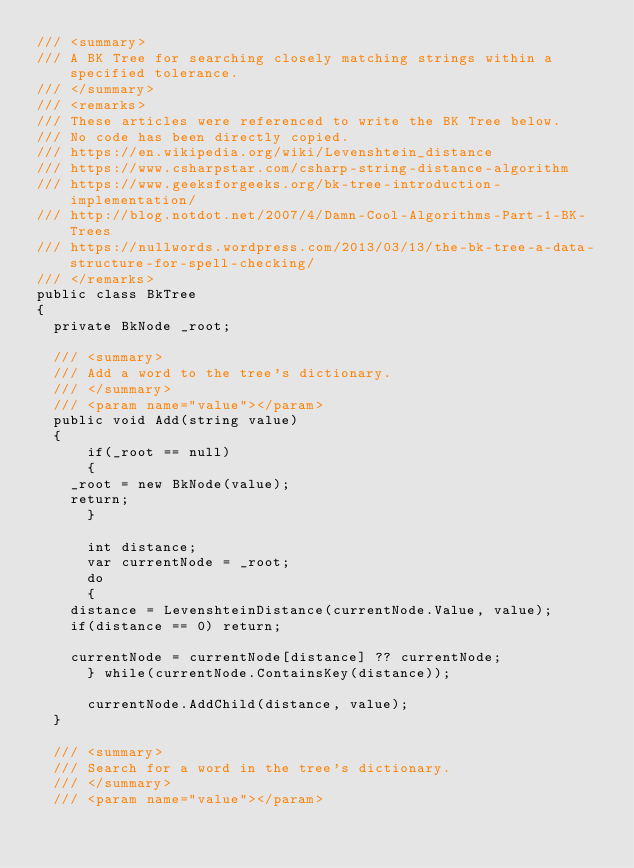<code> <loc_0><loc_0><loc_500><loc_500><_C#_>/// <summary>
/// A BK Tree for searching closely matching strings within a specified tolerance.
/// </summary>
/// <remarks>
/// These articles were referenced to write the BK Tree below.
/// No code has been directly copied.
/// https://en.wikipedia.org/wiki/Levenshtein_distance
/// https://www.csharpstar.com/csharp-string-distance-algorithm
/// https://www.geeksforgeeks.org/bk-tree-introduction-implementation/
/// http://blog.notdot.net/2007/4/Damn-Cool-Algorithms-Part-1-BK-Trees
/// https://nullwords.wordpress.com/2013/03/13/the-bk-tree-a-data-structure-for-spell-checking/
/// </remarks>
public class BkTree
{
	private BkNode _root;

	/// <summary>
	/// Add a word to the tree's dictionary.
	/// </summary>
	/// <param name="value"></param>
	public void Add(string value)
	{
	    if(_root == null)
	    {
		_root = new BkNode(value);
		return;
	    }

	    int distance;
	    var currentNode = _root;
	    do
	    {
		distance = LevenshteinDistance(currentNode.Value, value);
		if(distance == 0) return;

		currentNode = currentNode[distance] ?? currentNode;
	    } while(currentNode.ContainsKey(distance));

	    currentNode.AddChild(distance, value);
	}

	/// <summary>
	/// Search for a word in the tree's dictionary.
	/// </summary>
	/// <param name="value"></param></code> 